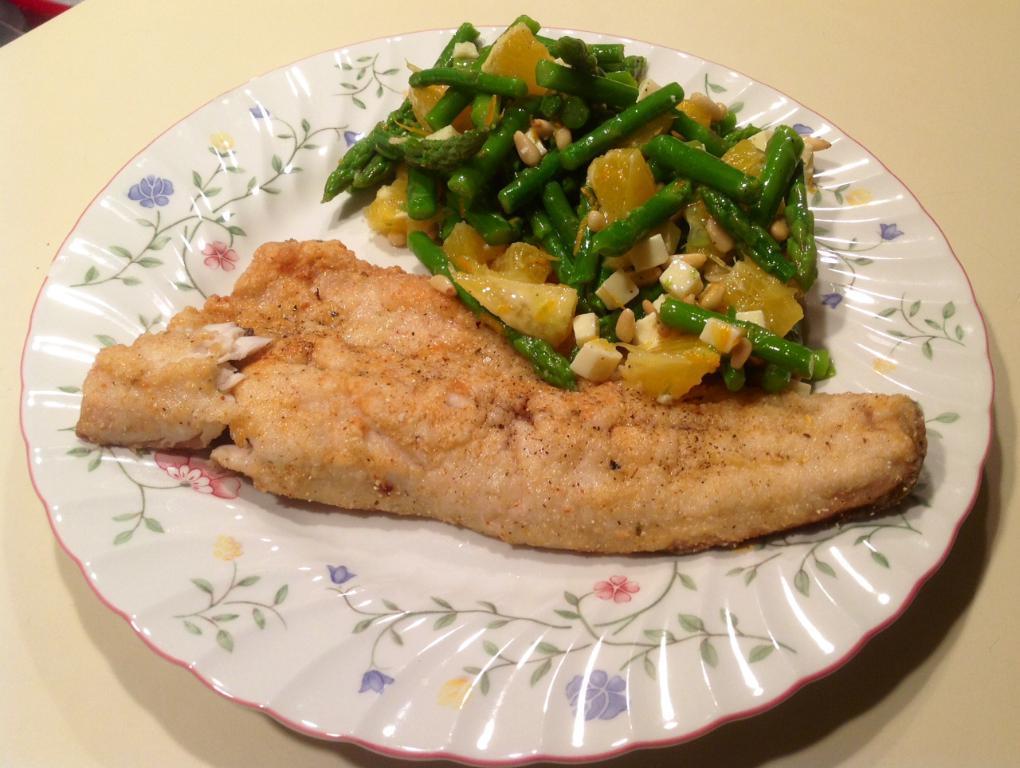Please provide a concise description of this image. In this picture there is a plate on the table. In the plate there is a meat and some veggies. 